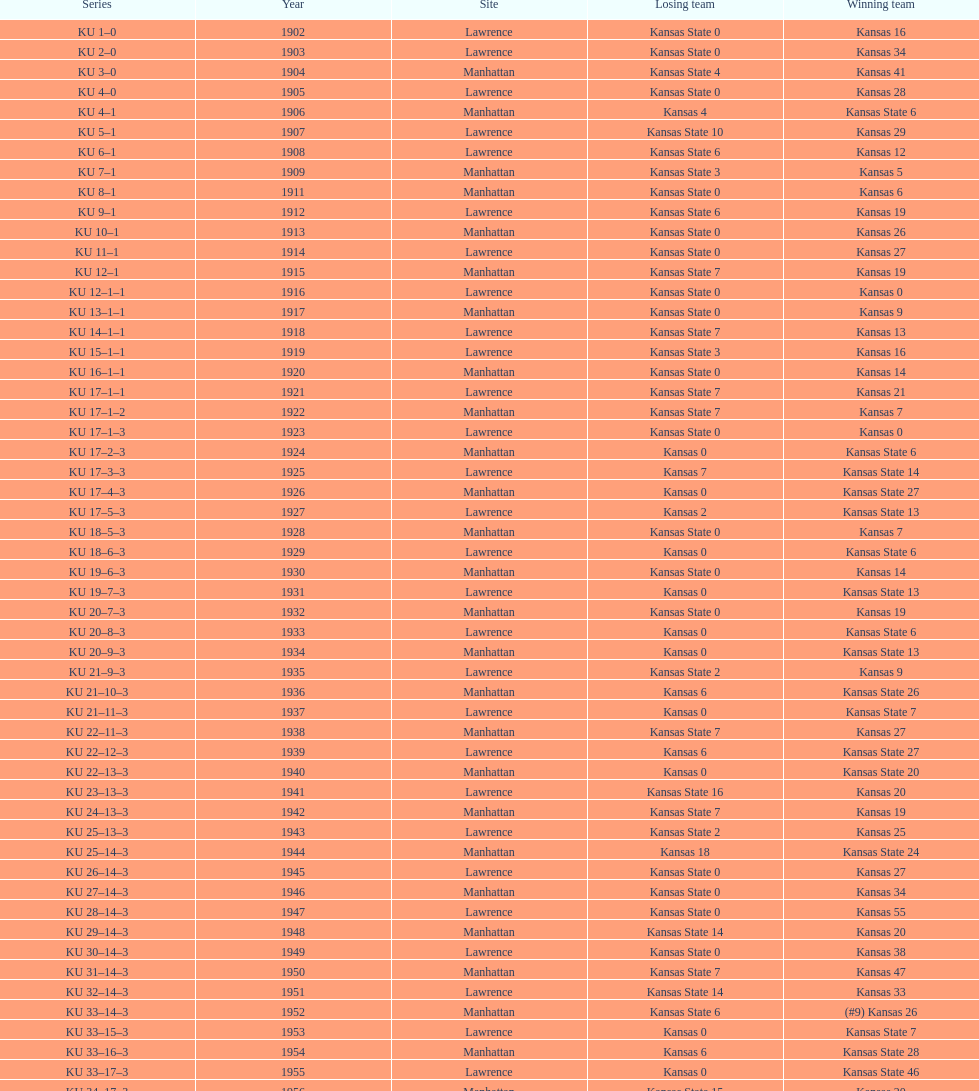How many times did kansas beat kansas state before 1910? 7. 